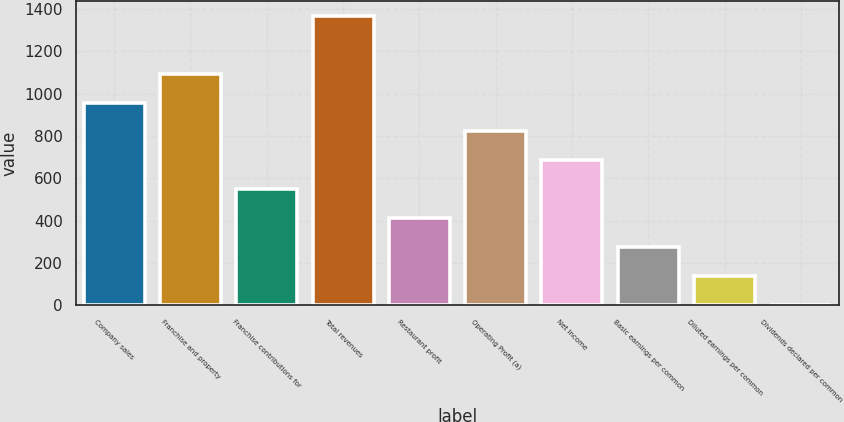Convert chart. <chart><loc_0><loc_0><loc_500><loc_500><bar_chart><fcel>Company sales<fcel>Franchise and property<fcel>Franchise contributions for<fcel>Total revenues<fcel>Restaurant profit<fcel>Operating Profit (a)<fcel>Net Income<fcel>Basic earnings per common<fcel>Diluted earnings per common<fcel>Dividends declared per common<nl><fcel>957.68<fcel>1094.44<fcel>547.4<fcel>1368<fcel>410.64<fcel>820.92<fcel>684.16<fcel>273.88<fcel>137.12<fcel>0.36<nl></chart> 